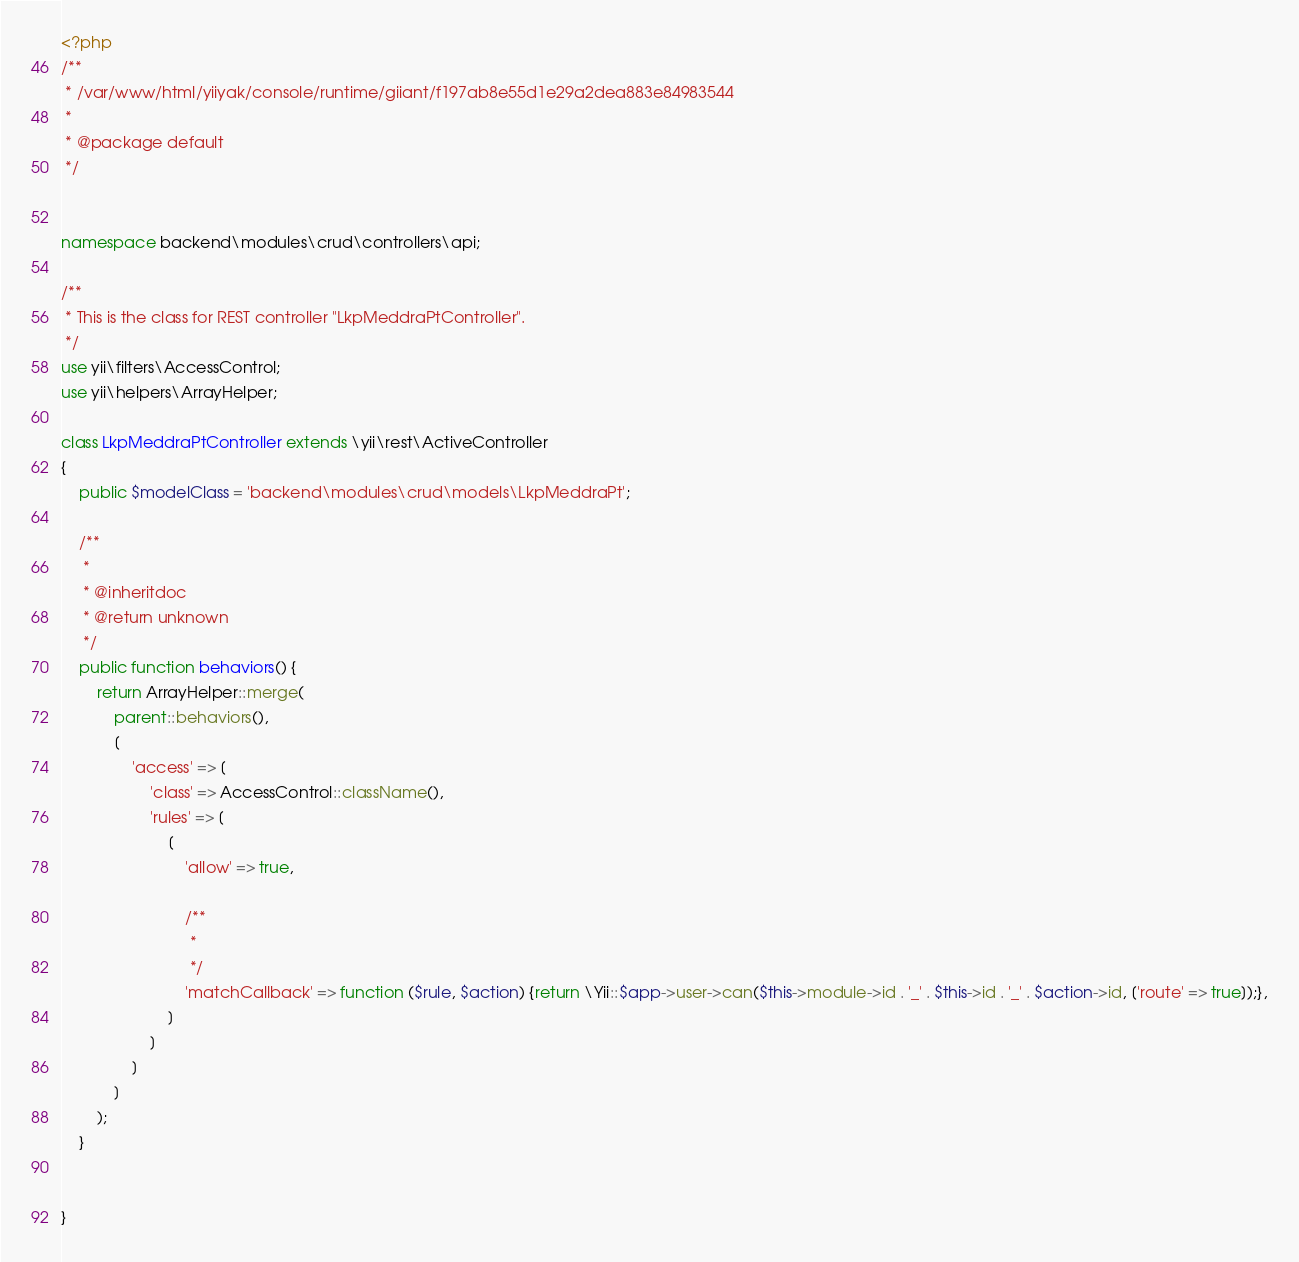<code> <loc_0><loc_0><loc_500><loc_500><_PHP_><?php
/**
 * /var/www/html/yiiyak/console/runtime/giiant/f197ab8e55d1e29a2dea883e84983544
 *
 * @package default
 */


namespace backend\modules\crud\controllers\api;

/**
 * This is the class for REST controller "LkpMeddraPtController".
 */
use yii\filters\AccessControl;
use yii\helpers\ArrayHelper;

class LkpMeddraPtController extends \yii\rest\ActiveController
{
	public $modelClass = 'backend\modules\crud\models\LkpMeddraPt';

	/**
	 *
	 * @inheritdoc
	 * @return unknown
	 */
	public function behaviors() {
		return ArrayHelper::merge(
			parent::behaviors(),
			[
				'access' => [
					'class' => AccessControl::className(),
					'rules' => [
						[
							'allow' => true,

							/**
							 *
							 */
							'matchCallback' => function ($rule, $action) {return \Yii::$app->user->can($this->module->id . '_' . $this->id . '_' . $action->id, ['route' => true]);},
						]
					]
				]
			]
		);
	}


}
</code> 